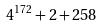<formula> <loc_0><loc_0><loc_500><loc_500>4 ^ { 1 7 2 } + 2 + 2 5 8</formula> 